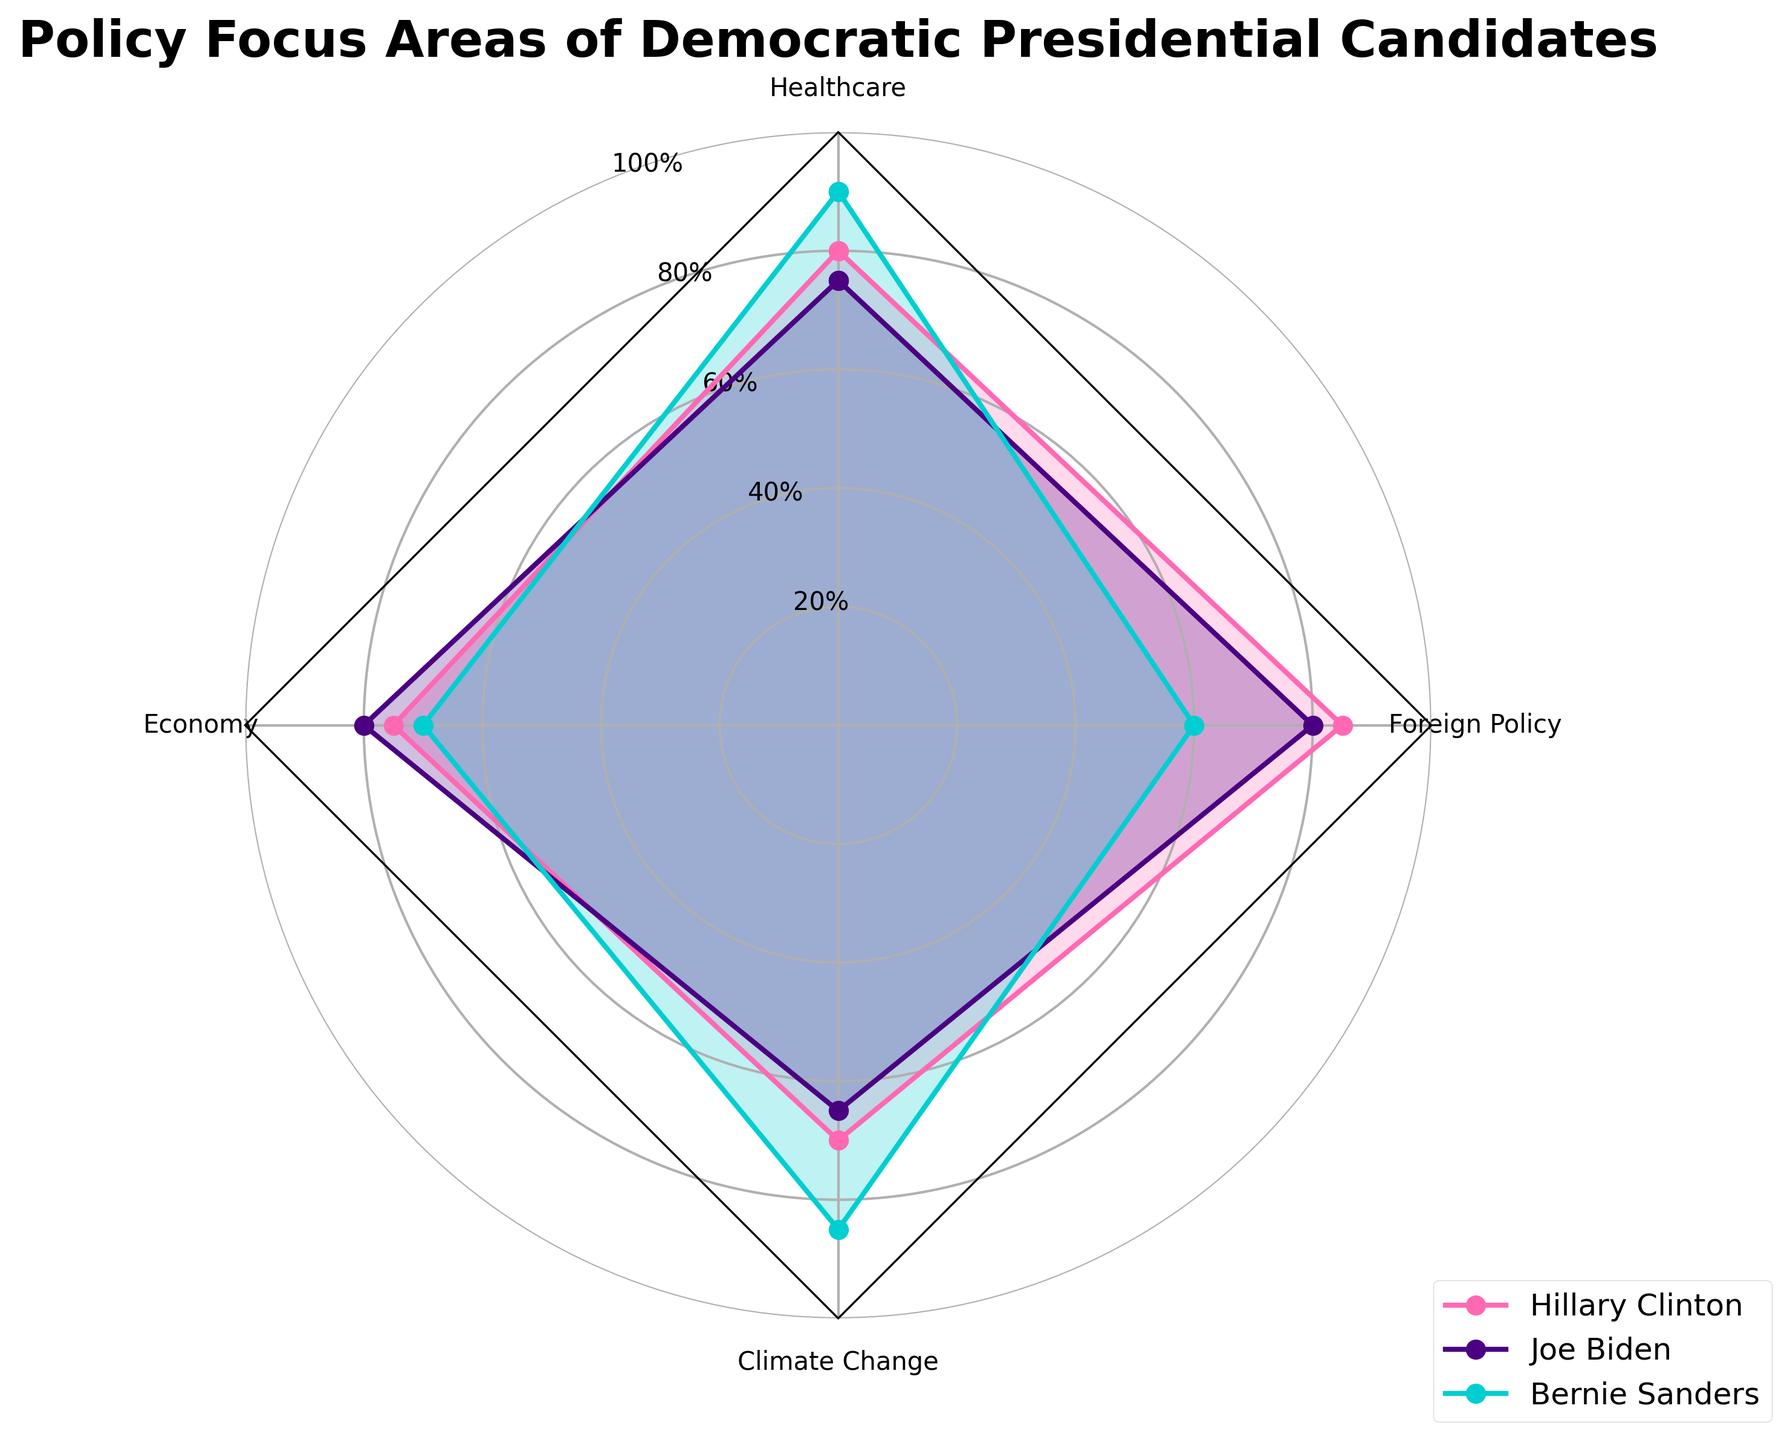What's the title of the radar chart? The title is usually displayed at the top of the chart in bold. According to the data and code provided, the title set by the `plt.title` function is "Policy Focus Areas of Democratic Presidential Candidates".
Answer: Policy Focus Areas of Democratic Presidential Candidates Which candidate has the highest focus on Healthcare? To identify this, we look at the section labeled "Healthcare" in the radar chart and compare the highest point among the candidates. Bernie Sanders reaches the highest point at 90.
Answer: Bernie Sanders Which policy area does Joe Biden emphasize the most? We observe Joe Biden's line on the radar chart and find the highest value among the four policy areas: Healthcare, Economy, Climate Change, and Foreign Policy. The highest value is 80 in "Economy" and "Foreign Policy".
Answer: Economy and Foreign Policy How does Hillary Clinton's focus on Climate Change compare to Joe Biden's? By looking at the "Climate Change" section on the radar chart, we compare the values for Hillary Clinton and Joe Biden. Hillary Clinton has a value of 70, while Joe Biden has a value of 65. Therefore, Hillary Clinton has a higher focus.
Answer: Hillary Clinton has a higher focus What is the average focus on Foreign Policy among the three candidates? To calculate the average focus on Foreign Policy, add up the values for Hillary Clinton (85), Joe Biden (80), and Bernie Sanders (60), then divide by the number of candidates, which is 3. The calculation is (85 + 80 + 60) / 3 = 75.
Answer: 75 Which candidate has the lowest focus on Foreign Policy? Look at the "Foreign Policy" section of the radar chart and identify the candidate with the lowest point. Bernie Sanders has the lowest value at 60.
Answer: Bernie Sanders Compare the Economy focus between Hillary Clinton and Bernie Sanders. Examine the "Economy" section of the radar chart. Hillary Clinton has a focus value of 75, while Bernie Sanders has a value of 70. Thus, Hillary Clinton has a higher focus on the Economy.
Answer: Hillary Clinton has a higher focus What is the combined focus on Healthcare for Hillary Clinton and Joe Biden? Add up the Healthcare values for the two candidates: Hillary Clinton (80) and Joe Biden (75). The sum is 80 + 75 = 155.
Answer: 155 